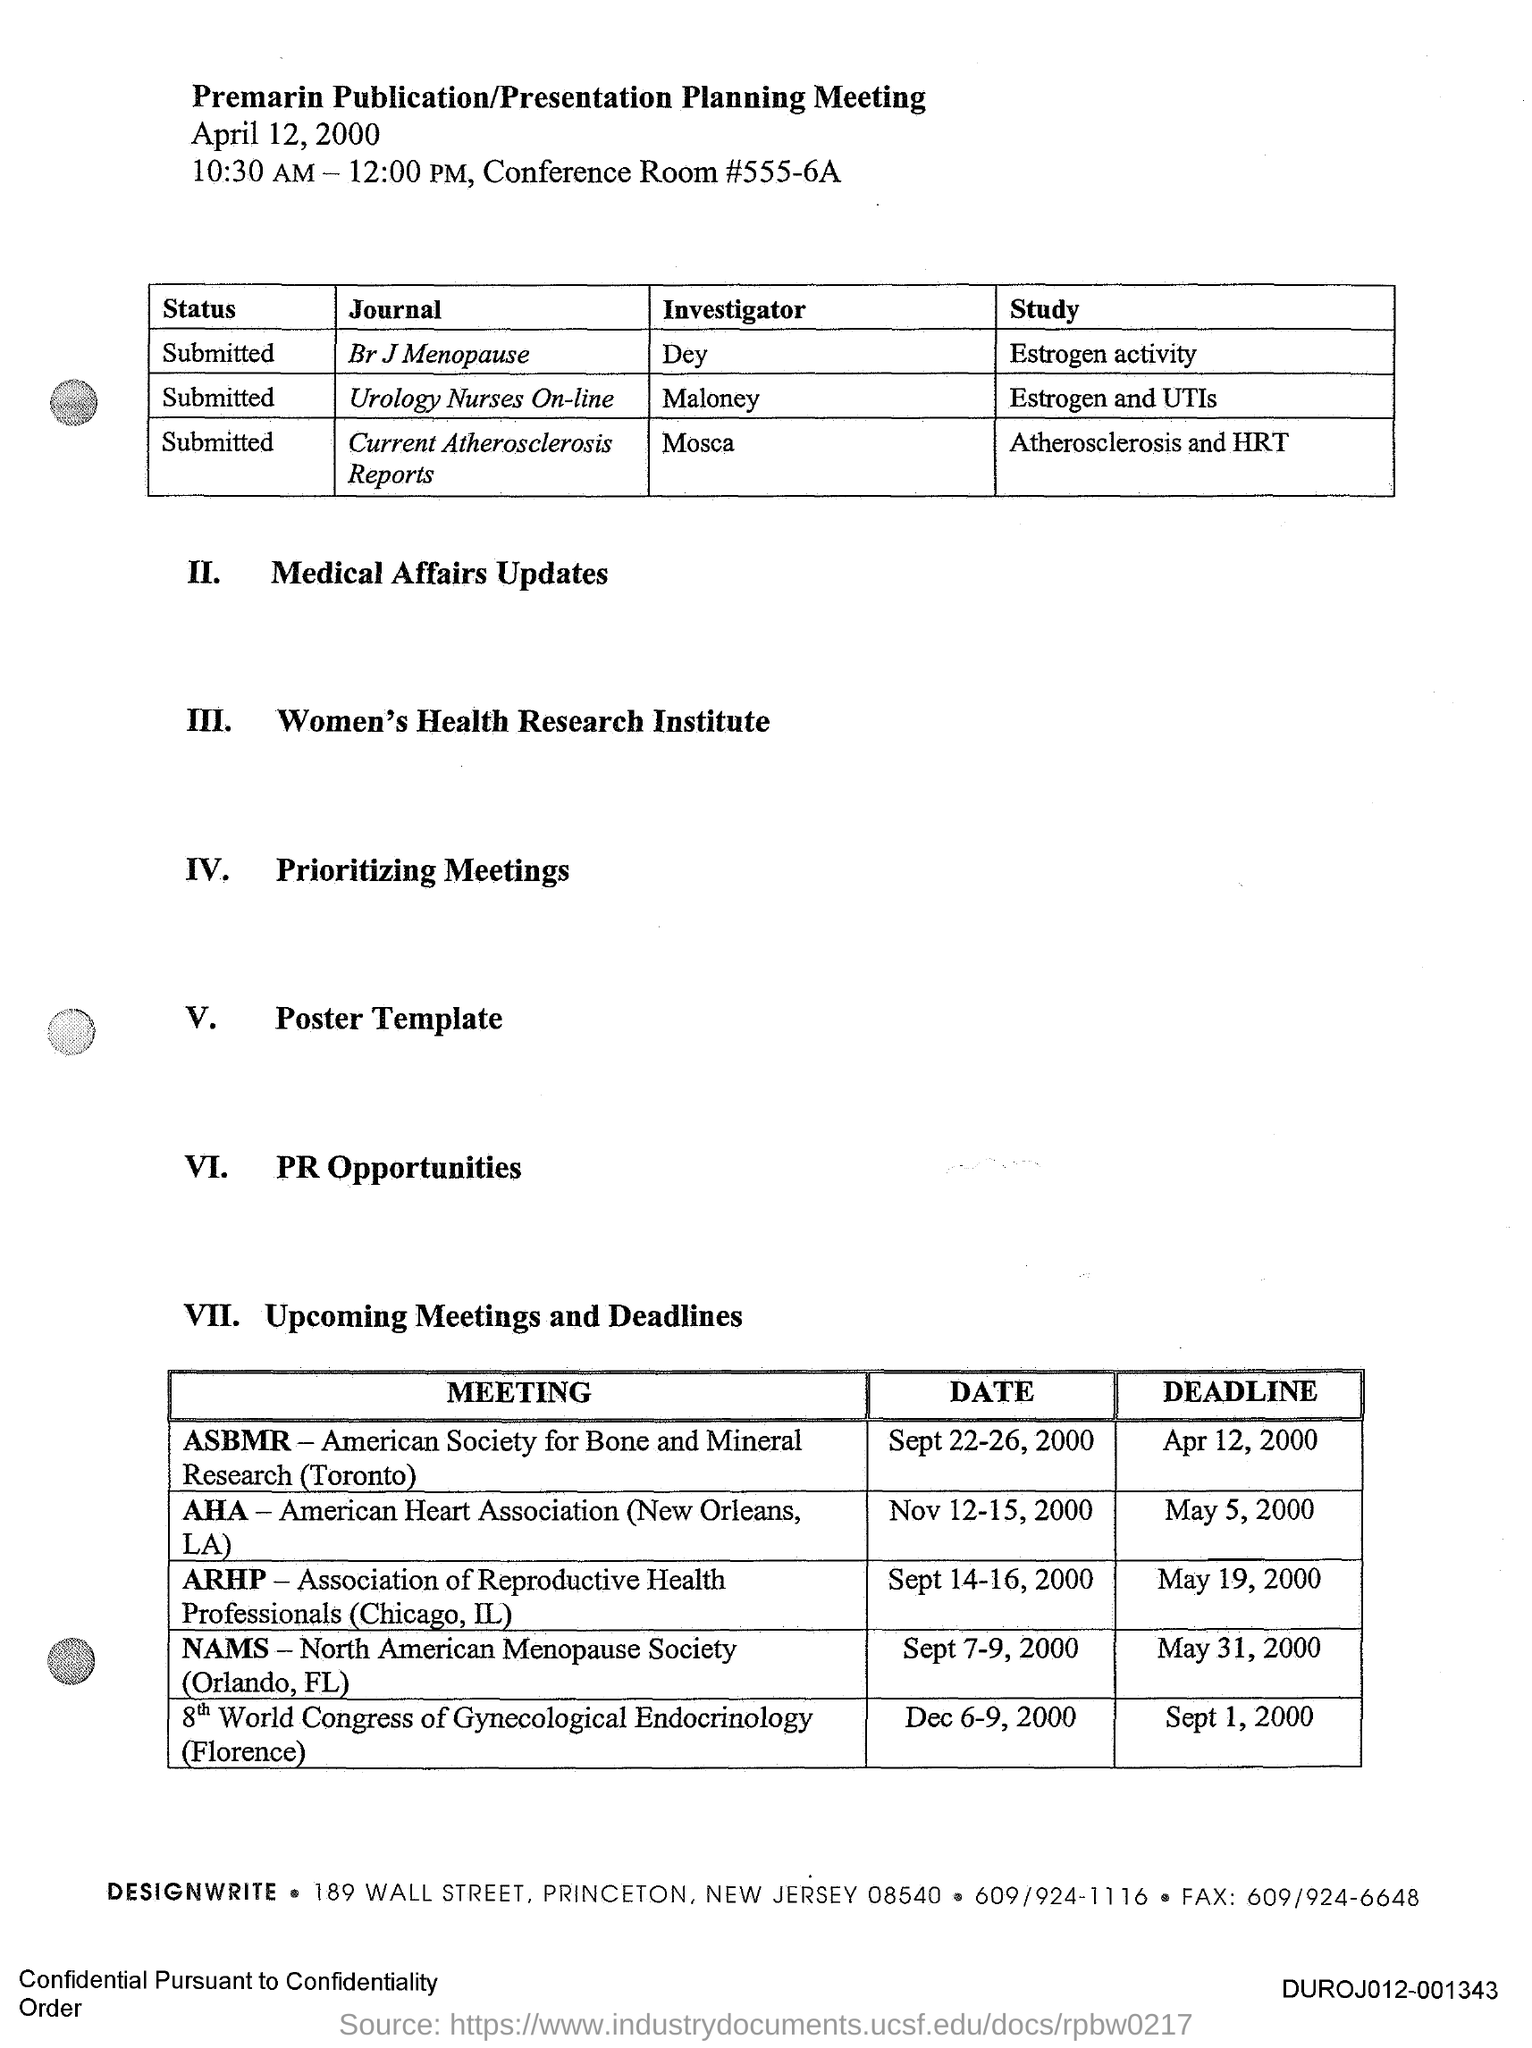What is the title of the document?
Offer a very short reply. Premarin Publication/Presentation Planning Meeting. Who is the Investigator for the journal Br J Menopause?
Your answer should be compact. Dey. Who is the Investigator for the journal Urology Nurses On-line?
Your response must be concise. Maloney. 